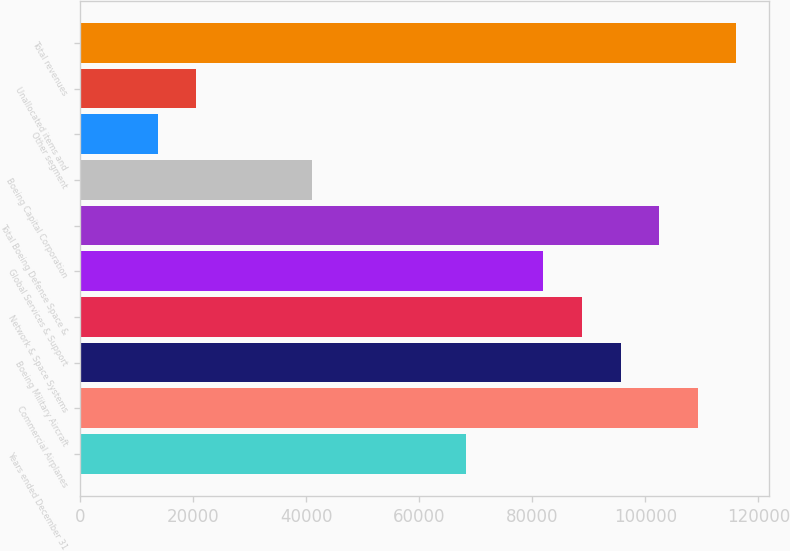Convert chart. <chart><loc_0><loc_0><loc_500><loc_500><bar_chart><fcel>Years ended December 31<fcel>Commercial Airplanes<fcel>Boeing Military Aircraft<fcel>Network & Space Systems<fcel>Global Services & Support<fcel>Total Boeing Defense Space &<fcel>Boeing Capital Corporation<fcel>Other segment<fcel>Unallocated items and<fcel>Total revenues<nl><fcel>68281<fcel>109236<fcel>95584.2<fcel>88758.4<fcel>81932.6<fcel>102410<fcel>40977.8<fcel>13674.6<fcel>20500.4<fcel>116062<nl></chart> 